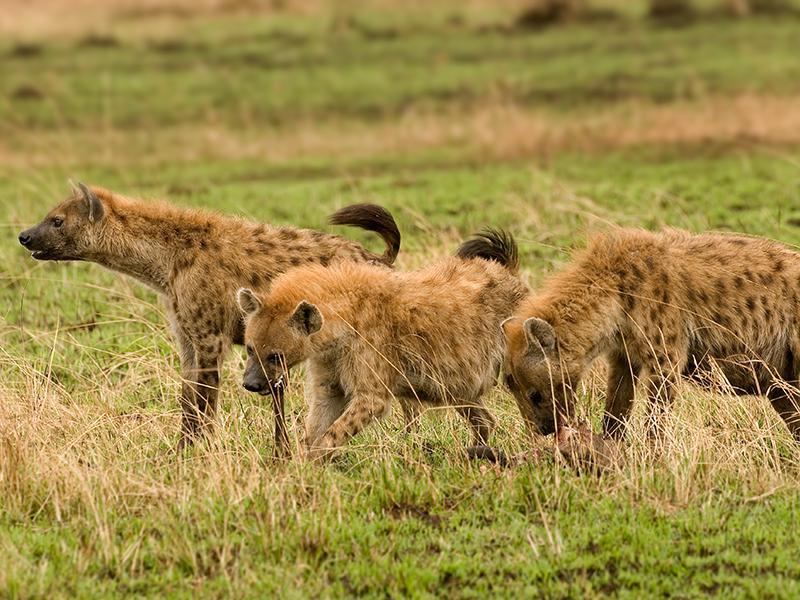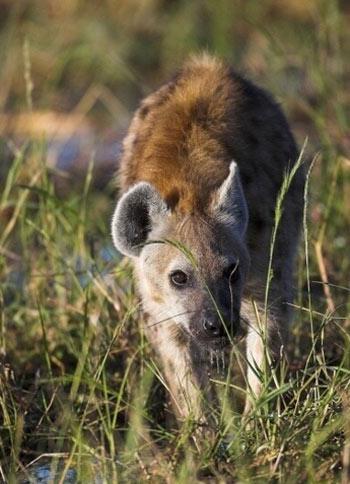The first image is the image on the left, the second image is the image on the right. Analyze the images presented: Is the assertion "There are exactly two hyenas in each image." valid? Answer yes or no. No. The first image is the image on the left, the second image is the image on the right. For the images displayed, is the sentence "There are exactly two hyenas in the image on the right." factually correct? Answer yes or no. No. 